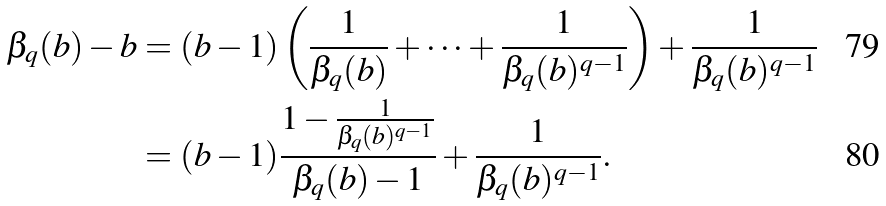<formula> <loc_0><loc_0><loc_500><loc_500>\beta _ { q } ( b ) - b & = ( b - 1 ) \left ( \frac { 1 } { \beta _ { q } ( b ) } + \cdots + \frac { 1 } { \beta _ { q } ( b ) ^ { q - 1 } } \right ) + \frac { 1 } { \beta _ { q } ( b ) ^ { q - 1 } } \\ & = ( b - 1 ) \frac { 1 - \frac { 1 } { \beta _ { q } ( b ) ^ { q - 1 } } } { \beta _ { q } ( b ) - 1 } + \frac { 1 } { \beta _ { q } ( b ) ^ { q - 1 } } .</formula> 